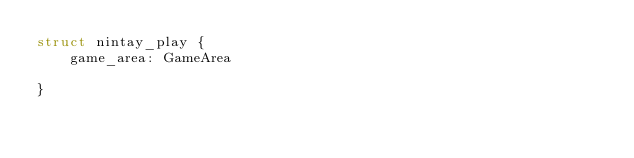<code> <loc_0><loc_0><loc_500><loc_500><_Rust_>struct nintay_play {
    game_area: GameArea

}</code> 